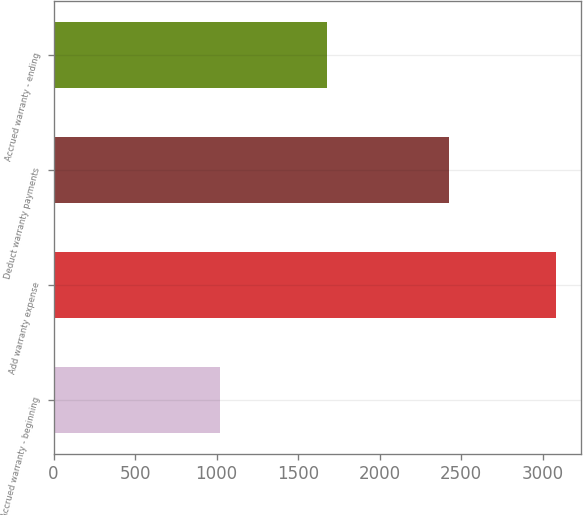Convert chart to OTSL. <chart><loc_0><loc_0><loc_500><loc_500><bar_chart><fcel>Accrued warranty - beginning<fcel>Add warranty expense<fcel>Deduct warranty payments<fcel>Accrued warranty - ending<nl><fcel>1021<fcel>3080<fcel>2426<fcel>1675<nl></chart> 